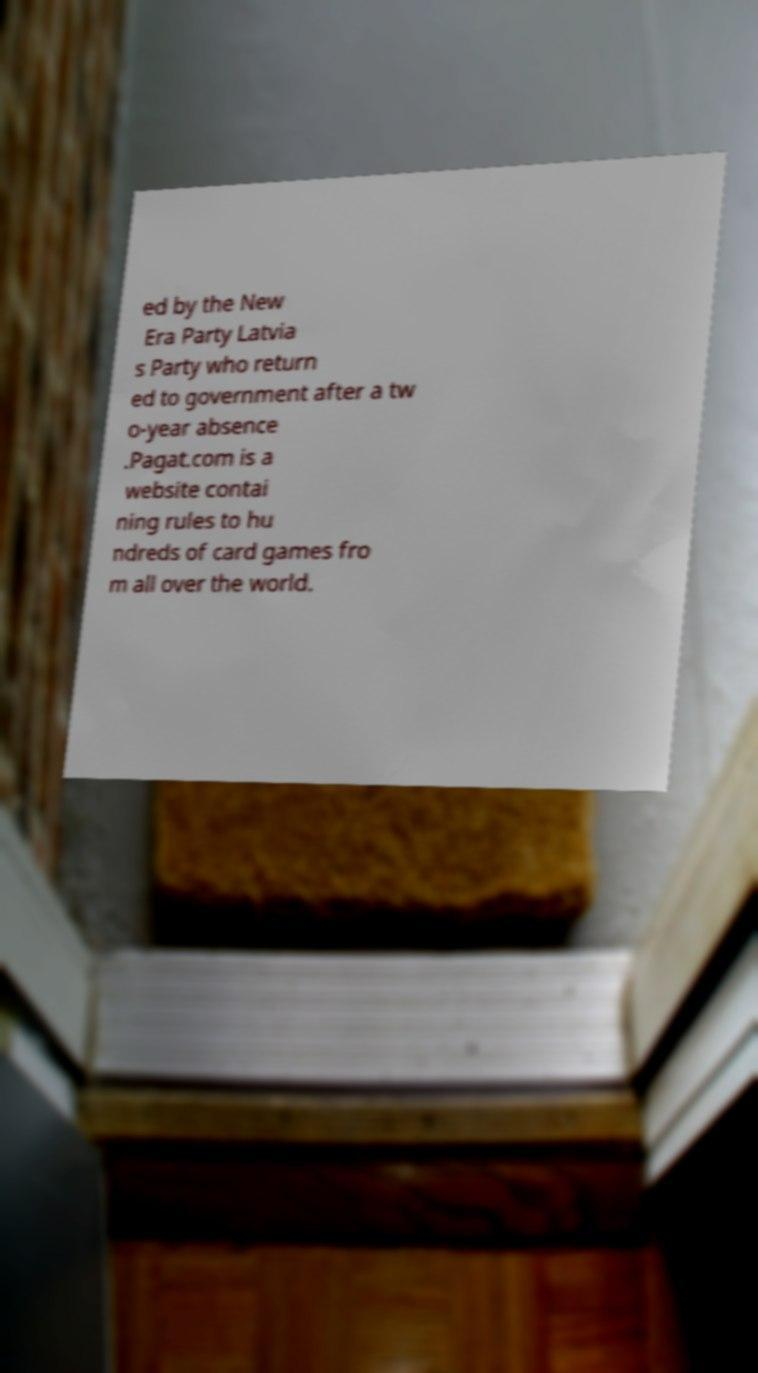There's text embedded in this image that I need extracted. Can you transcribe it verbatim? ed by the New Era Party Latvia s Party who return ed to government after a tw o-year absence .Pagat.com is a website contai ning rules to hu ndreds of card games fro m all over the world. 